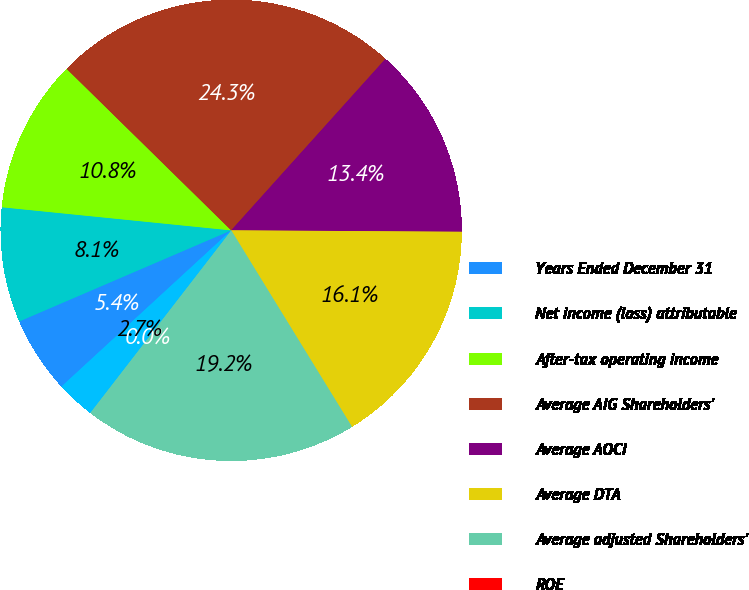Convert chart to OTSL. <chart><loc_0><loc_0><loc_500><loc_500><pie_chart><fcel>Years Ended December 31<fcel>Net income (loss) attributable<fcel>After-tax operating income<fcel>Average AIG Shareholders'<fcel>Average AOCI<fcel>Average DTA<fcel>Average adjusted Shareholders'<fcel>ROE<fcel>Adjusted Return on Equity<nl><fcel>5.38%<fcel>8.06%<fcel>10.75%<fcel>24.31%<fcel>13.44%<fcel>16.13%<fcel>19.24%<fcel>0.0%<fcel>2.69%<nl></chart> 